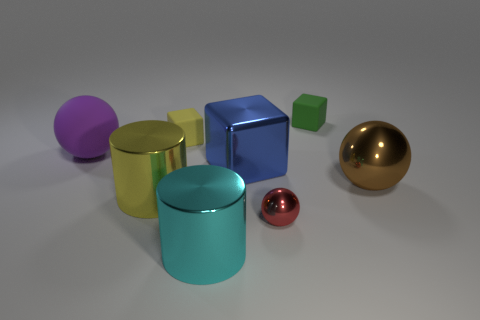Add 1 large brown metal spheres. How many objects exist? 9 Subtract all cylinders. How many objects are left? 6 Add 6 large gray metallic cubes. How many large gray metallic cubes exist? 6 Subtract 1 cyan cylinders. How many objects are left? 7 Subtract all tiny balls. Subtract all big brown balls. How many objects are left? 6 Add 6 green rubber objects. How many green rubber objects are left? 7 